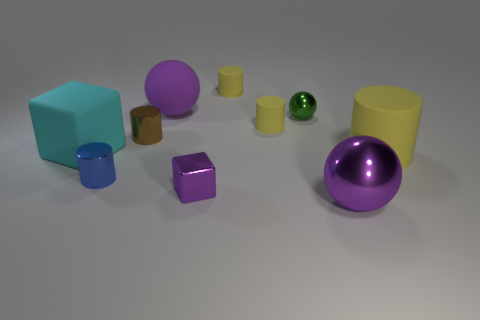Subtract all yellow blocks. How many yellow cylinders are left? 3 Subtract all brown cylinders. How many cylinders are left? 4 Subtract all purple spheres. How many spheres are left? 1 Subtract all balls. How many objects are left? 7 Subtract all cyan cylinders. Subtract all gray blocks. How many cylinders are left? 5 Add 10 tiny purple rubber cylinders. How many tiny purple rubber cylinders exist? 10 Subtract 0 purple cylinders. How many objects are left? 10 Subtract all tiny metal cylinders. Subtract all green balls. How many objects are left? 7 Add 5 big matte cylinders. How many big matte cylinders are left? 6 